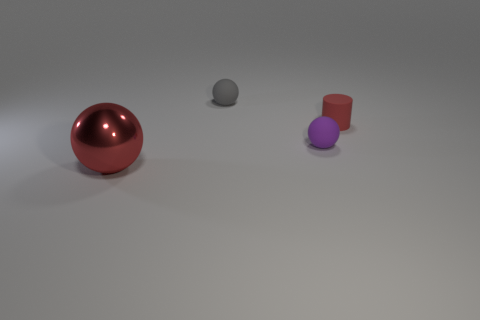What is the texture of the surface on which the objects are placed? The surface appears smooth and matte, with a slight gradient suggesting a gentle light source, creating a soft shadow beneath each object. 